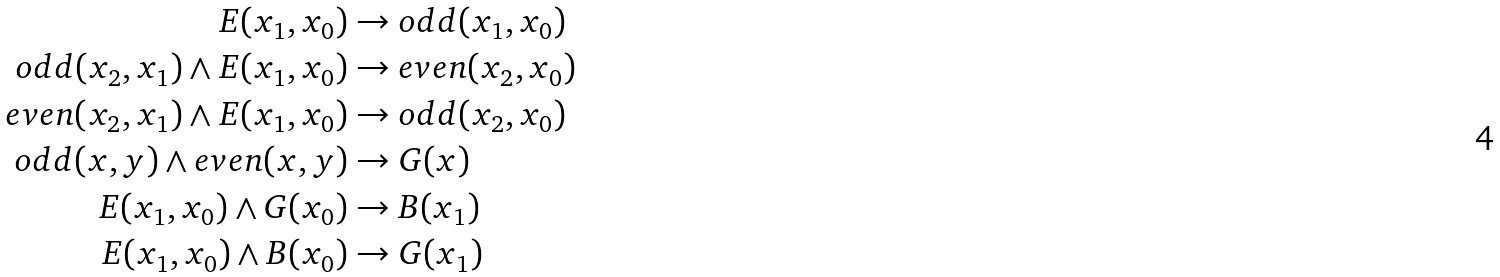<formula> <loc_0><loc_0><loc_500><loc_500>E ( x _ { 1 } , x _ { 0 } ) & \rightarrow o d d ( x _ { 1 } , x _ { 0 } ) \\ o d d ( x _ { 2 } , x _ { 1 } ) \wedge E ( x _ { 1 } , x _ { 0 } ) & \rightarrow e v e n ( x _ { 2 } , x _ { 0 } ) \\ e v e n ( x _ { 2 } , x _ { 1 } ) \wedge E ( x _ { 1 } , x _ { 0 } ) & \rightarrow o d d ( x _ { 2 } , x _ { 0 } ) \\ o d d ( x , y ) \wedge e v e n ( x , y ) & \rightarrow G ( x ) \\ E ( x _ { 1 } , x _ { 0 } ) \wedge G ( x _ { 0 } ) & \rightarrow B ( x _ { 1 } ) \\ E ( x _ { 1 } , x _ { 0 } ) \wedge B ( x _ { 0 } ) & \rightarrow G ( x _ { 1 } )</formula> 